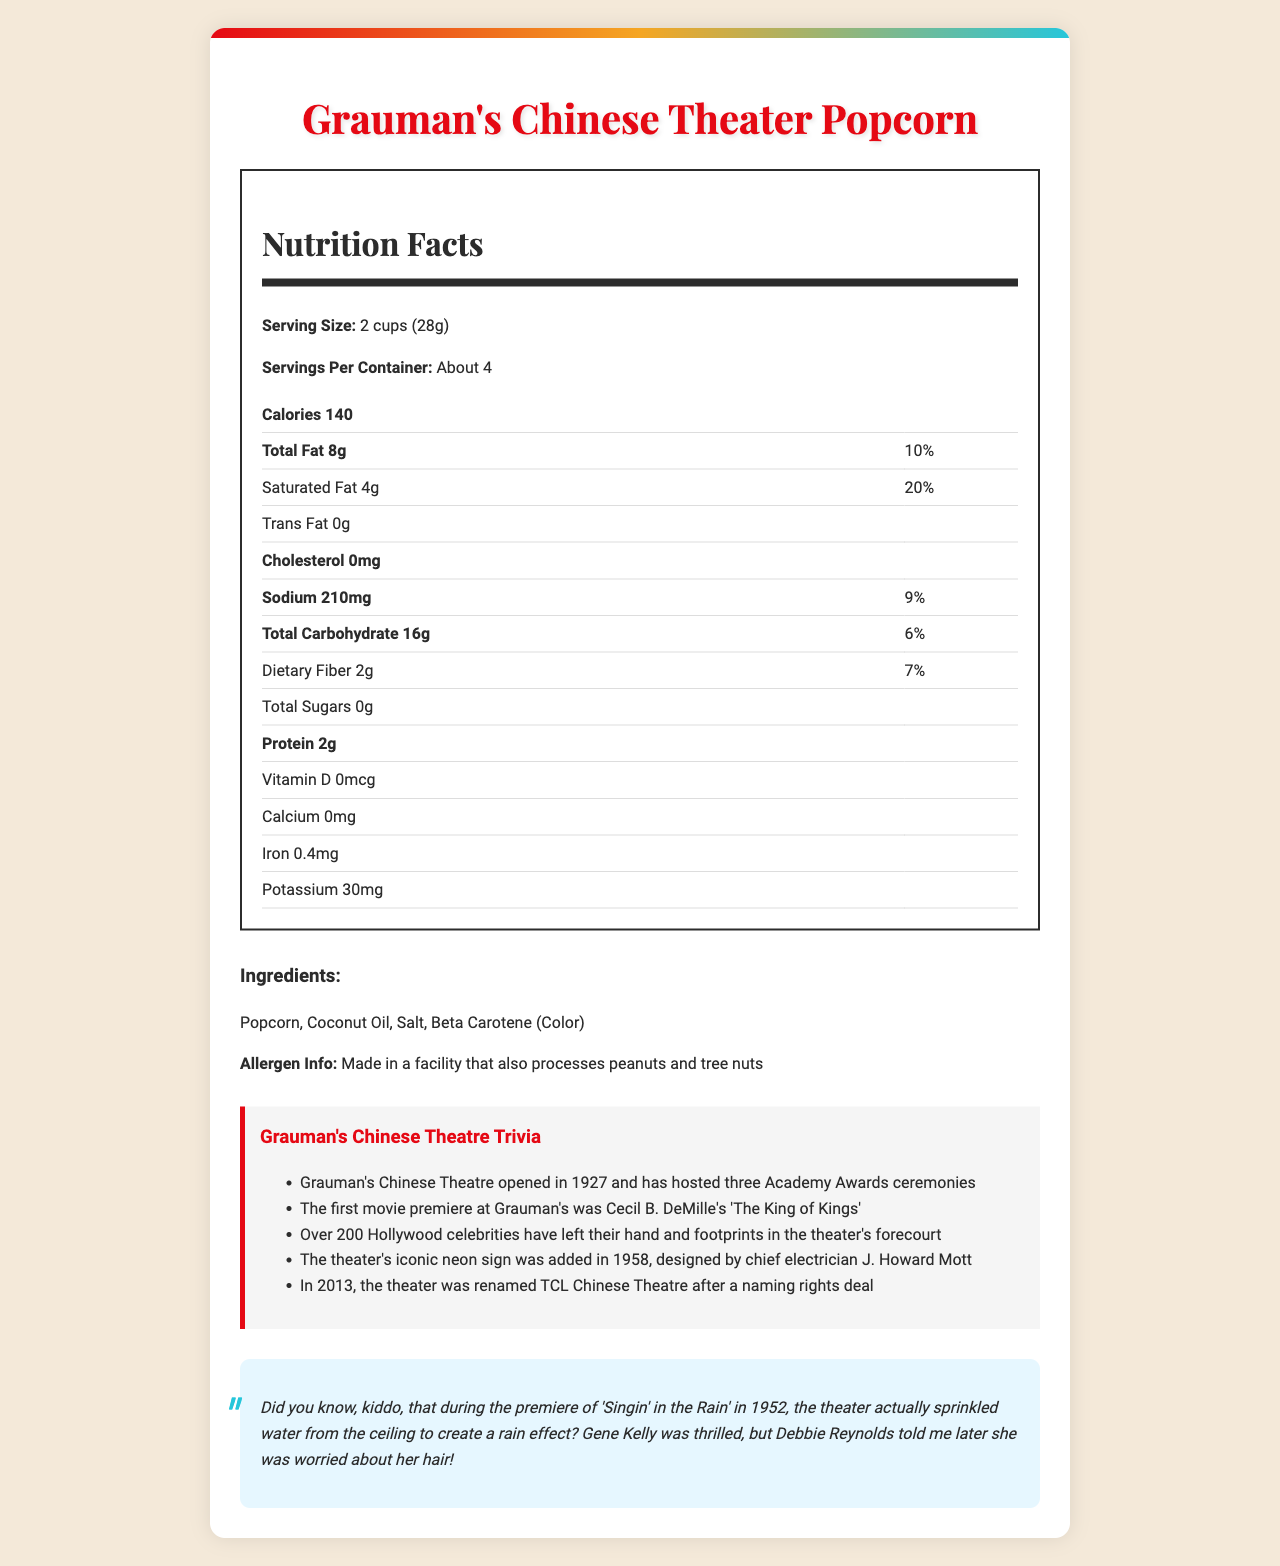who is the chief electrician that designed the iconic neon sign for Grauman's Chinese Theatre? The document states that the theater's iconic neon sign was added in 1958 and was designed by J. Howard Mott, the chief electrician.
Answer: J. Howard Mott how many servings are in one container of Grauman's Chinese Theater Popcorn? The document specifies that the container has about 4 servings.
Answer: About 4 what is the sodium content per serving? The Nutrition Facts section indicates that each serving contains 210mg of sodium.
Answer: 210mg what event took place at Grauman's Chinese Theatre in 1927? The document states that Grauman's Chinese Theatre opened in 1927.
Answer: The opening of Grauman's Chinese Theatre what ingredient gives the popcorn its color? The ingredient list shows that Beta Carotene (Color) is used for coloring the popcorn.
Answer: Beta Carotene which movie was the first to premiere at Grauman's Chinese Theatre? A. Gone with the Wind B. The King of Kings C. Casablanca The document mentions that the first movie premiere at Grauman's was Cecil B. DeMille's "The King of Kings."
Answer: B. The King of Kings what is the total fat content percentage per serving? A. 8% B. 10% C. 15% The Nutrition Facts section indicates the total fat content is 8g, which is 10% of the daily value.
Answer: B. 10% is the document about a fictional or real product? The document provides detailed nutritional information and trivia related to an actual product, making it appear to be a real product.
Answer: Real Product summarize the main idea of the document The document detailedly explains "Grauman's Chinese Theater Popcorn," including its nutritional content, serving size, ingredients, and unique trivia about Grauman's Chinese Theatre.
Answer: The document provides detailed nutritional information for "Grauman's Chinese Theater Popcorn." It includes serving size, servings per container, calories, fats, sodium, carbohydrates, proteins, vitamins, minerals, and ingredients. It also includes allergen information, trivia about Grauman's Chinese Theatre, and a Hollywood anecdote. did Grauman's Chinese Theatre ever host an Academy Awards ceremony? The document mentions that Grauman's Chinese Theatre has hosted three Academy Awards ceremonies.
Answer: Yes what was sprinkled from the ceiling during 'Singin' in the Rain' premiere? The Hollywood anecdote section of the document mentions that water was sprinkled from the ceiling during the premiere.
Answer: Water how much potassium is in one serving of Grauman's Chinese Theater Popcorn? The Nutrition Facts section states that each serving contains 30mg of potassium.
Answer: 30mg is there any vitamin D in "Grauman's Chinese Theater Popcorn"? The Nutrition Facts indicate that there is 0mcg of Vitamin D in the popcorn.
Answer: No how many Hollywood celebrities have left their hand and footprints in Grauman's Chinese Theatre's forecourt? The trivia section states that over 200 Hollywood celebrities have left their hand and footprints in the theater's forecourt.
Answer: Over 200 when was Grauman's Chinese Theatre renamed TCL Chinese Theatre? The trivia mentions that in 2013, the theater was renamed TCL Chinese Theatre after a naming rights deal.
Answer: 2013 what's the main source of fat in Grauman's Chinese Theater Popcorn? The ingredients list includes Coconut Oil, which is the likely source of fat.
Answer: Coconut Oil why was Debbie Reynolds worried during the premiere of 'Singin' in the Rain'? The Hollywood anecdote reveals that Debbie Reynolds was concerned about her hair due to the water sprinkling during the premiere.
Answer: She was worried about her hair getting wet are there any tree nuts processed in the same facility as this popcorn? The allergen info states that the popcorn is made in a facility that also processes peanuts and tree nuts.
Answer: Yes what is the correct spelling of the theater's name after it was renamed in 2013? A. TLC Chinese Theatre B. TSL Chinese Theatre C. TCL Chinese Theatre The document mentions that the theater was renamed TCL Chinese Theatre after a naming rights deal in 2013.
Answer: C. TCL Chinese Theatre who hosted "Singin' in the Rain" premiere at Grauman's Chinese Theatre? The document does not provide information about who hosted "Singin' in the Rain" premiere, only that water was sprinkled and Gene Kelly and Debbie Reynolds attended.
Answer: Cannot be determined 